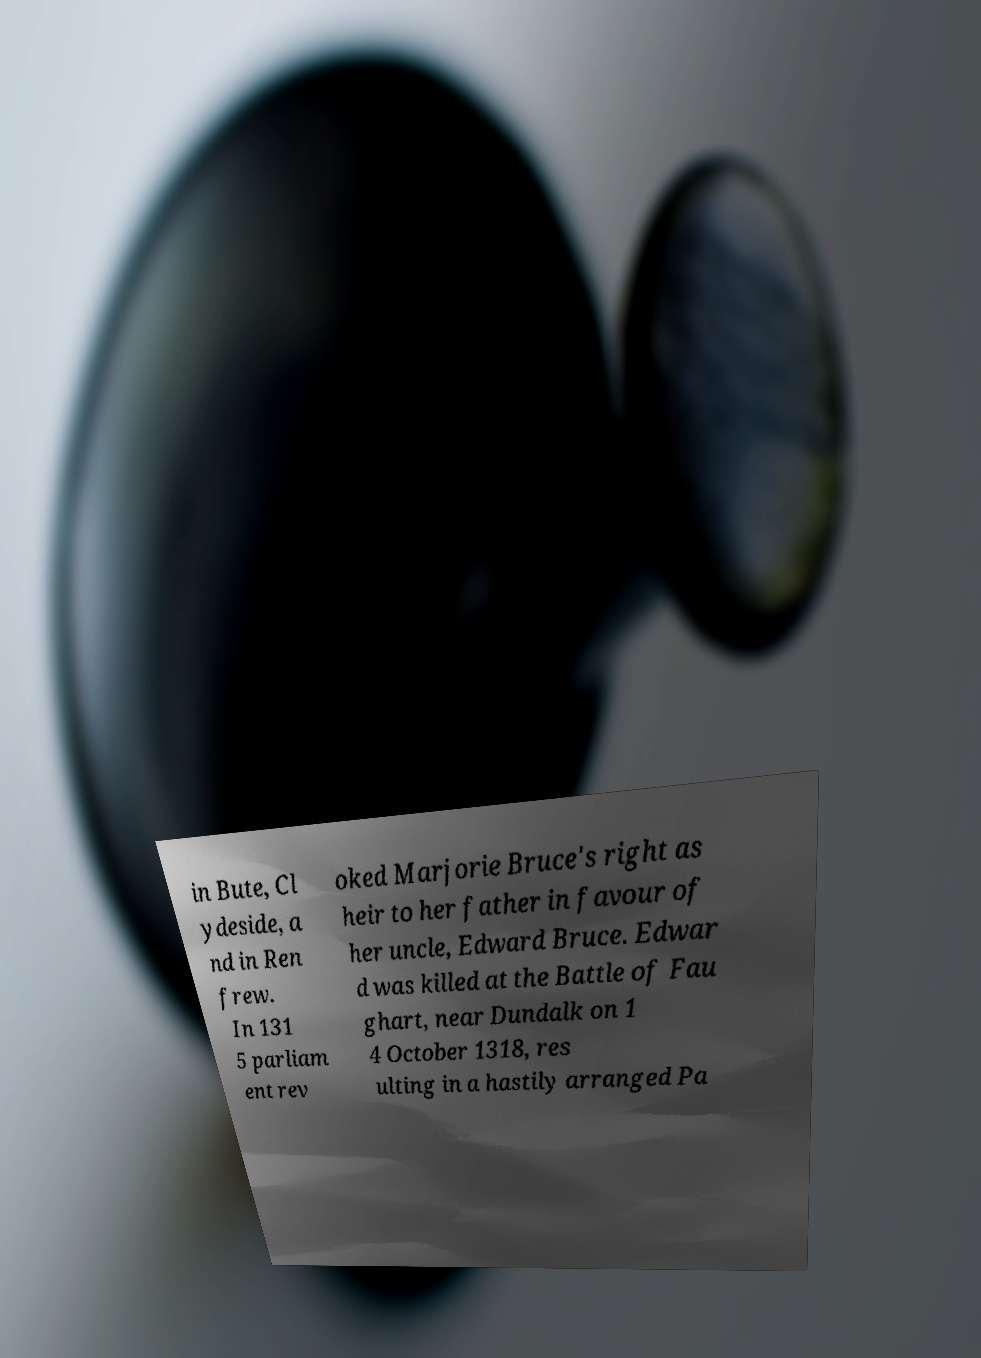There's text embedded in this image that I need extracted. Can you transcribe it verbatim? in Bute, Cl ydeside, a nd in Ren frew. In 131 5 parliam ent rev oked Marjorie Bruce's right as heir to her father in favour of her uncle, Edward Bruce. Edwar d was killed at the Battle of Fau ghart, near Dundalk on 1 4 October 1318, res ulting in a hastily arranged Pa 